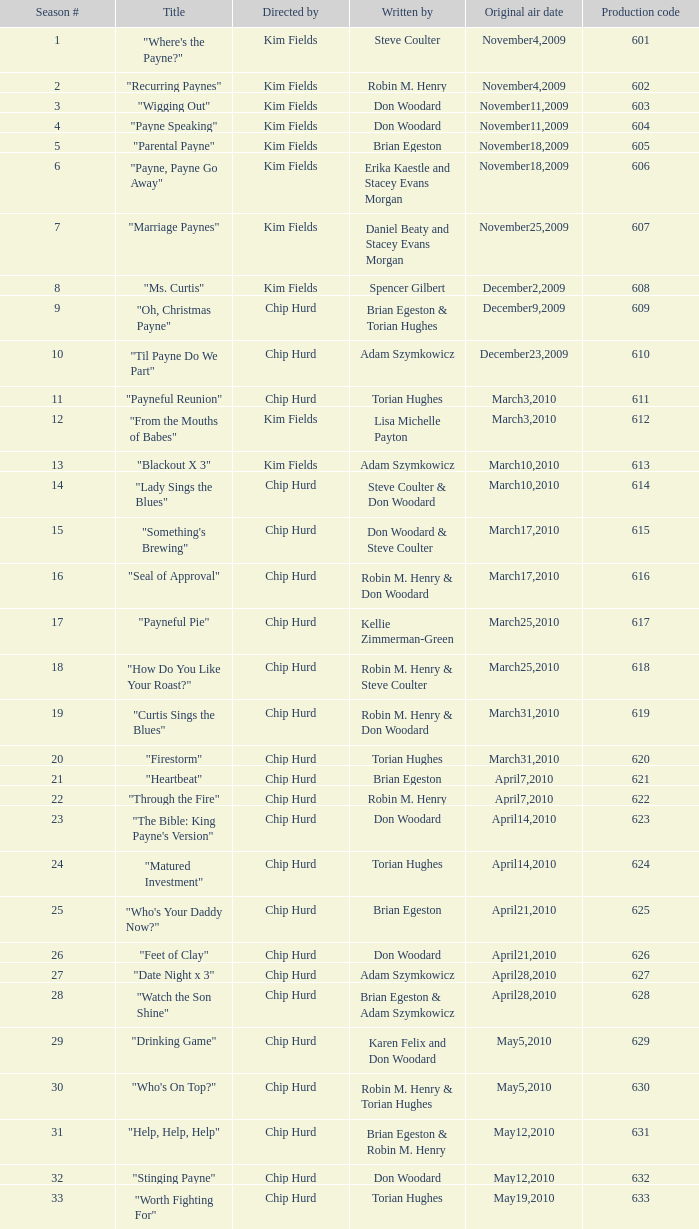What is the title of the episode with the production code 624? "Matured Investment". 